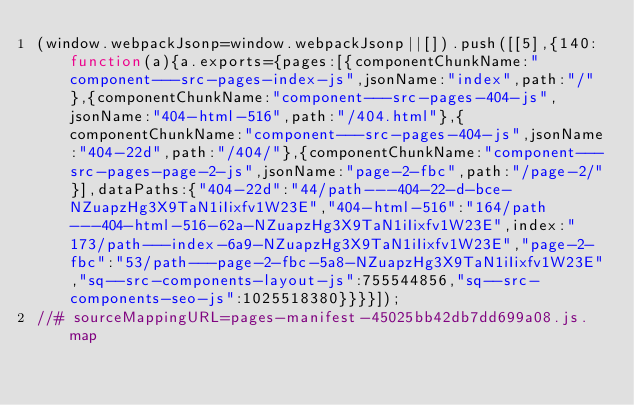Convert code to text. <code><loc_0><loc_0><loc_500><loc_500><_JavaScript_>(window.webpackJsonp=window.webpackJsonp||[]).push([[5],{140:function(a){a.exports={pages:[{componentChunkName:"component---src-pages-index-js",jsonName:"index",path:"/"},{componentChunkName:"component---src-pages-404-js",jsonName:"404-html-516",path:"/404.html"},{componentChunkName:"component---src-pages-404-js",jsonName:"404-22d",path:"/404/"},{componentChunkName:"component---src-pages-page-2-js",jsonName:"page-2-fbc",path:"/page-2/"}],dataPaths:{"404-22d":"44/path---404-22-d-bce-NZuapzHg3X9TaN1iIixfv1W23E","404-html-516":"164/path---404-html-516-62a-NZuapzHg3X9TaN1iIixfv1W23E",index:"173/path---index-6a9-NZuapzHg3X9TaN1iIixfv1W23E","page-2-fbc":"53/path---page-2-fbc-5a8-NZuapzHg3X9TaN1iIixfv1W23E","sq--src-components-layout-js":755544856,"sq--src-components-seo-js":1025518380}}}}]);
//# sourceMappingURL=pages-manifest-45025bb42db7dd699a08.js.map</code> 